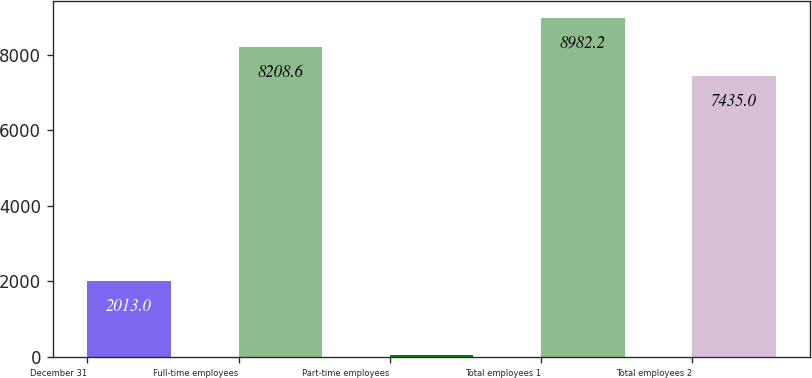Convert chart to OTSL. <chart><loc_0><loc_0><loc_500><loc_500><bar_chart><fcel>December 31<fcel>Full-time employees<fcel>Part-time employees<fcel>Total employees 1<fcel>Total employees 2<nl><fcel>2013<fcel>8208.6<fcel>45<fcel>8982.2<fcel>7435<nl></chart> 